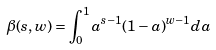<formula> <loc_0><loc_0><loc_500><loc_500>\beta ( s , w ) = \int _ { 0 } ^ { 1 } a ^ { s - 1 } ( 1 - a ) ^ { w - 1 } d a</formula> 